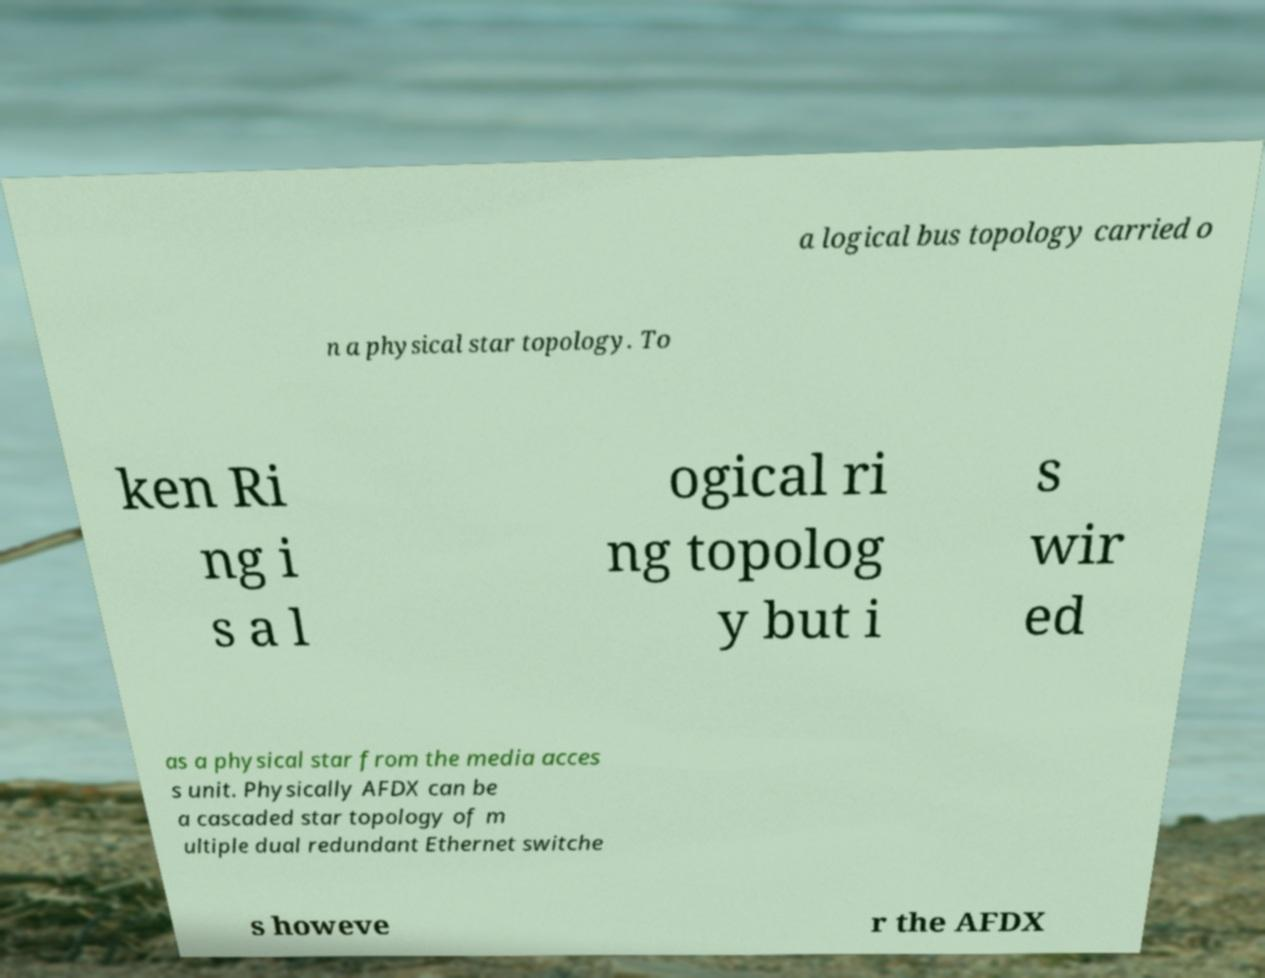There's text embedded in this image that I need extracted. Can you transcribe it verbatim? a logical bus topology carried o n a physical star topology. To ken Ri ng i s a l ogical ri ng topolog y but i s wir ed as a physical star from the media acces s unit. Physically AFDX can be a cascaded star topology of m ultiple dual redundant Ethernet switche s howeve r the AFDX 